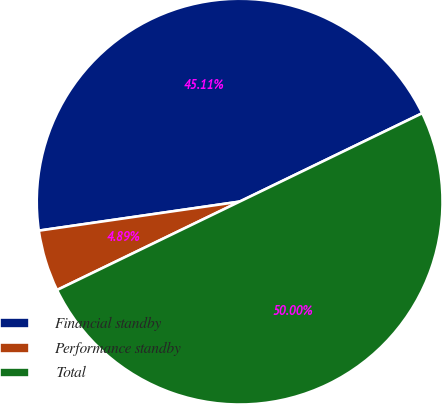Convert chart. <chart><loc_0><loc_0><loc_500><loc_500><pie_chart><fcel>Financial standby<fcel>Performance standby<fcel>Total<nl><fcel>45.11%<fcel>4.89%<fcel>50.0%<nl></chart> 